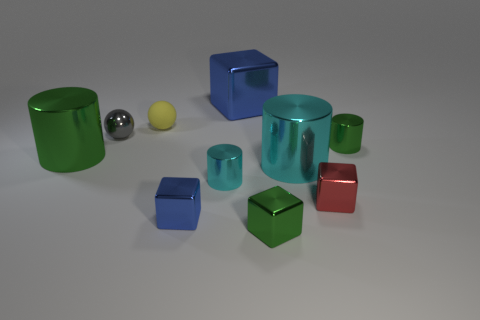What number of other things are made of the same material as the large cube?
Keep it short and to the point. 8. Are there more big yellow metallic blocks than large cyan cylinders?
Your response must be concise. No. Do the object behind the matte thing and the shiny ball have the same color?
Your response must be concise. No. What is the color of the tiny metallic ball?
Your answer should be very brief. Gray. Are there any small gray metallic spheres that are behind the blue block that is behind the tiny gray ball?
Your answer should be very brief. No. There is a gray metal thing that is behind the tiny green thing that is left of the red cube; what is its shape?
Make the answer very short. Sphere. Is the number of tiny purple rubber cylinders less than the number of yellow matte things?
Offer a terse response. Yes. Is the small yellow ball made of the same material as the small red thing?
Your response must be concise. No. There is a small metal thing that is both on the right side of the big cyan cylinder and in front of the small cyan shiny cylinder; what color is it?
Your answer should be very brief. Red. Is there a brown rubber cube of the same size as the gray metal ball?
Your response must be concise. No. 